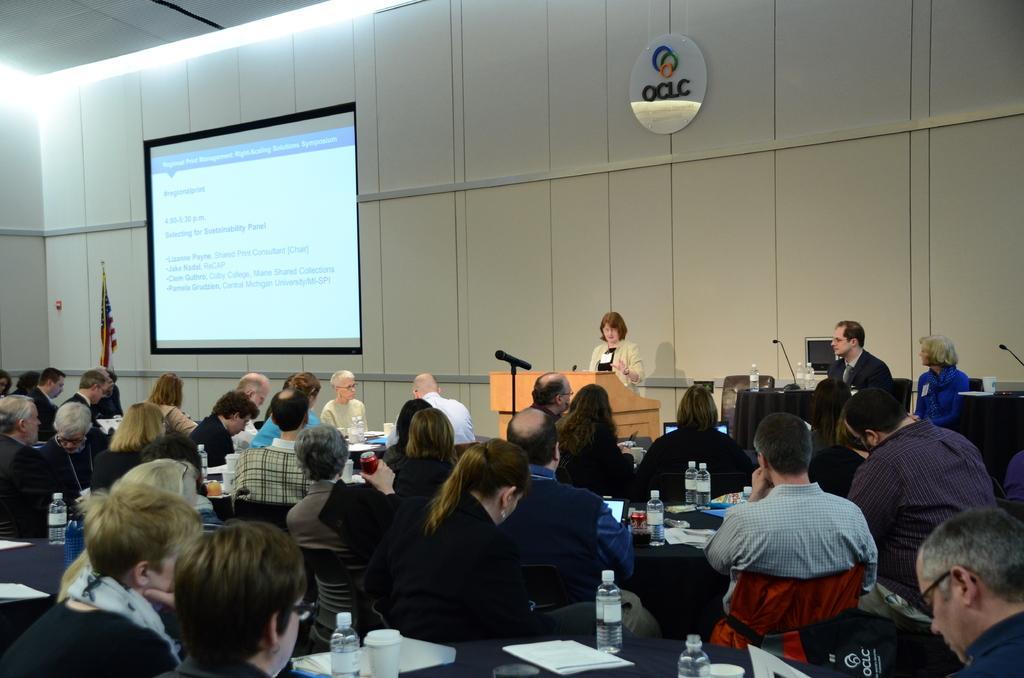How would you summarize this image in a sentence or two? In this image there are many people sitting on the chairs at the tables. On the table there are papers, bottles, drink cans and glasses. In front of them there is a woman standing at the podium. In front of the podium there is a microphone. Behind her there is a wall. To the left there is a projector board hanging on the wall. Beside the board there is a flag to the pole. At the top there is a board with logo on the wall. 